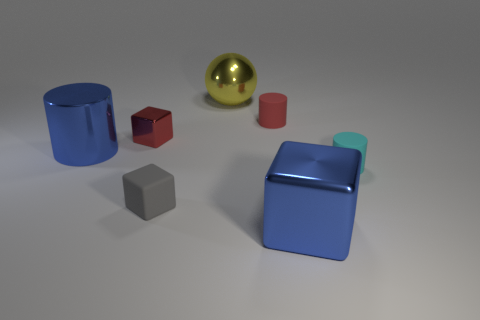Do the large cube and the metallic cylinder have the same color?
Offer a very short reply. Yes. Are there any other things that are the same size as the blue shiny cube?
Your response must be concise. Yes. What is the material of the small cylinder on the right side of the large cube right of the gray cube?
Give a very brief answer. Rubber. Are there the same number of metallic things that are to the left of the big yellow object and small things in front of the small metal thing?
Offer a very short reply. Yes. How many objects are big metallic things in front of the large shiny ball or tiny objects right of the big blue cube?
Provide a succinct answer. 3. The object that is left of the cyan thing and on the right side of the tiny red rubber cylinder is made of what material?
Offer a very short reply. Metal. There is a metallic block that is in front of the rubber cylinder to the right of the big blue metal object right of the tiny red block; what is its size?
Give a very brief answer. Large. Are there more blue metal cubes than large brown spheres?
Provide a succinct answer. Yes. Is the thing that is on the right side of the blue metallic cube made of the same material as the blue cylinder?
Offer a terse response. No. Are there fewer yellow things than purple blocks?
Make the answer very short. No. 